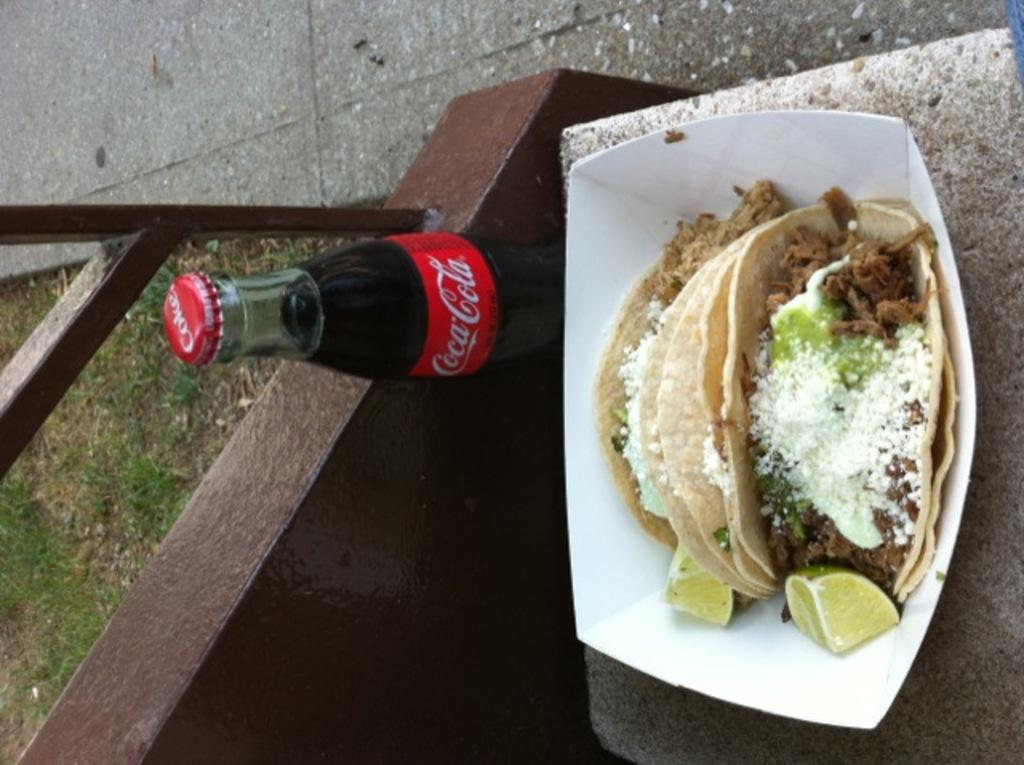What is the main subject of the image? There is a snack item on a bench. What else can be seen in the image? There is a cold drink bottle behind the snack. What type of environment is visible in the image? There is grass visible behind the food. What type of beam is holding up the caption in the image? There is no beam or caption present in the image. 